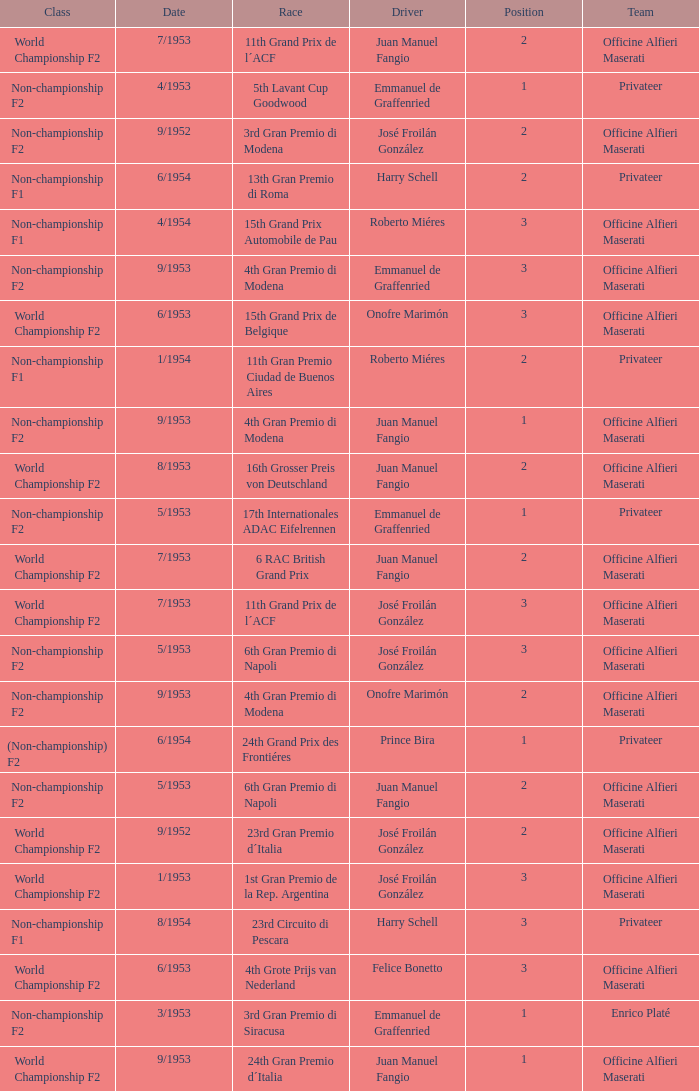What date has the class of non-championship f2 as well as a driver name josé froilán gonzález that has a position larger than 2? 5/1953. 